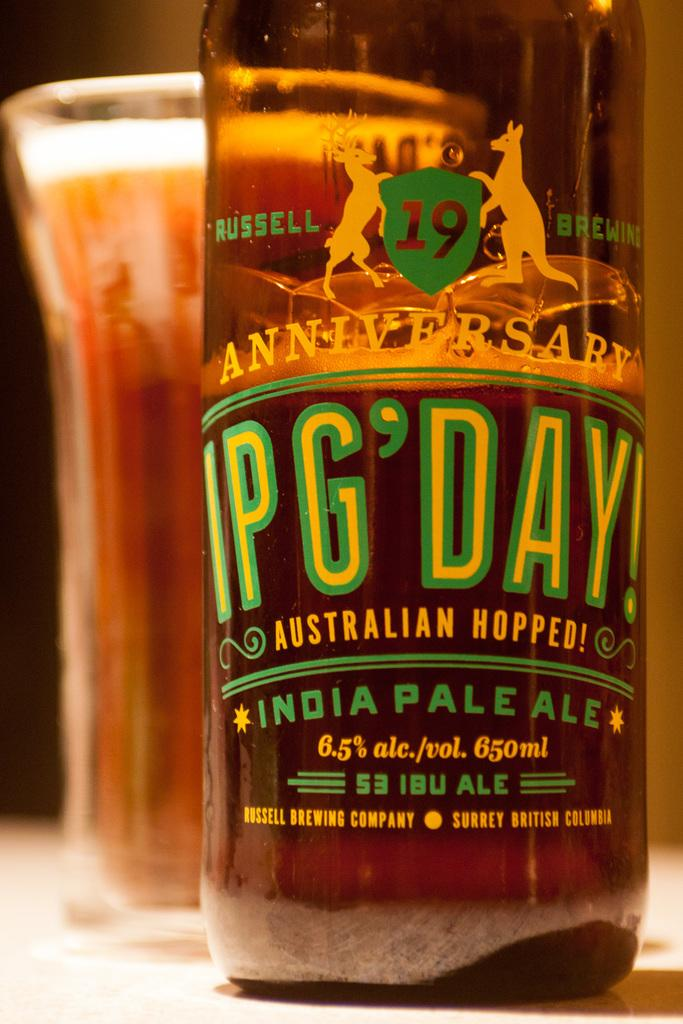Provide a one-sentence caption for the provided image. A bottle of an Australian hopped India Pale Ale sits on a table. 